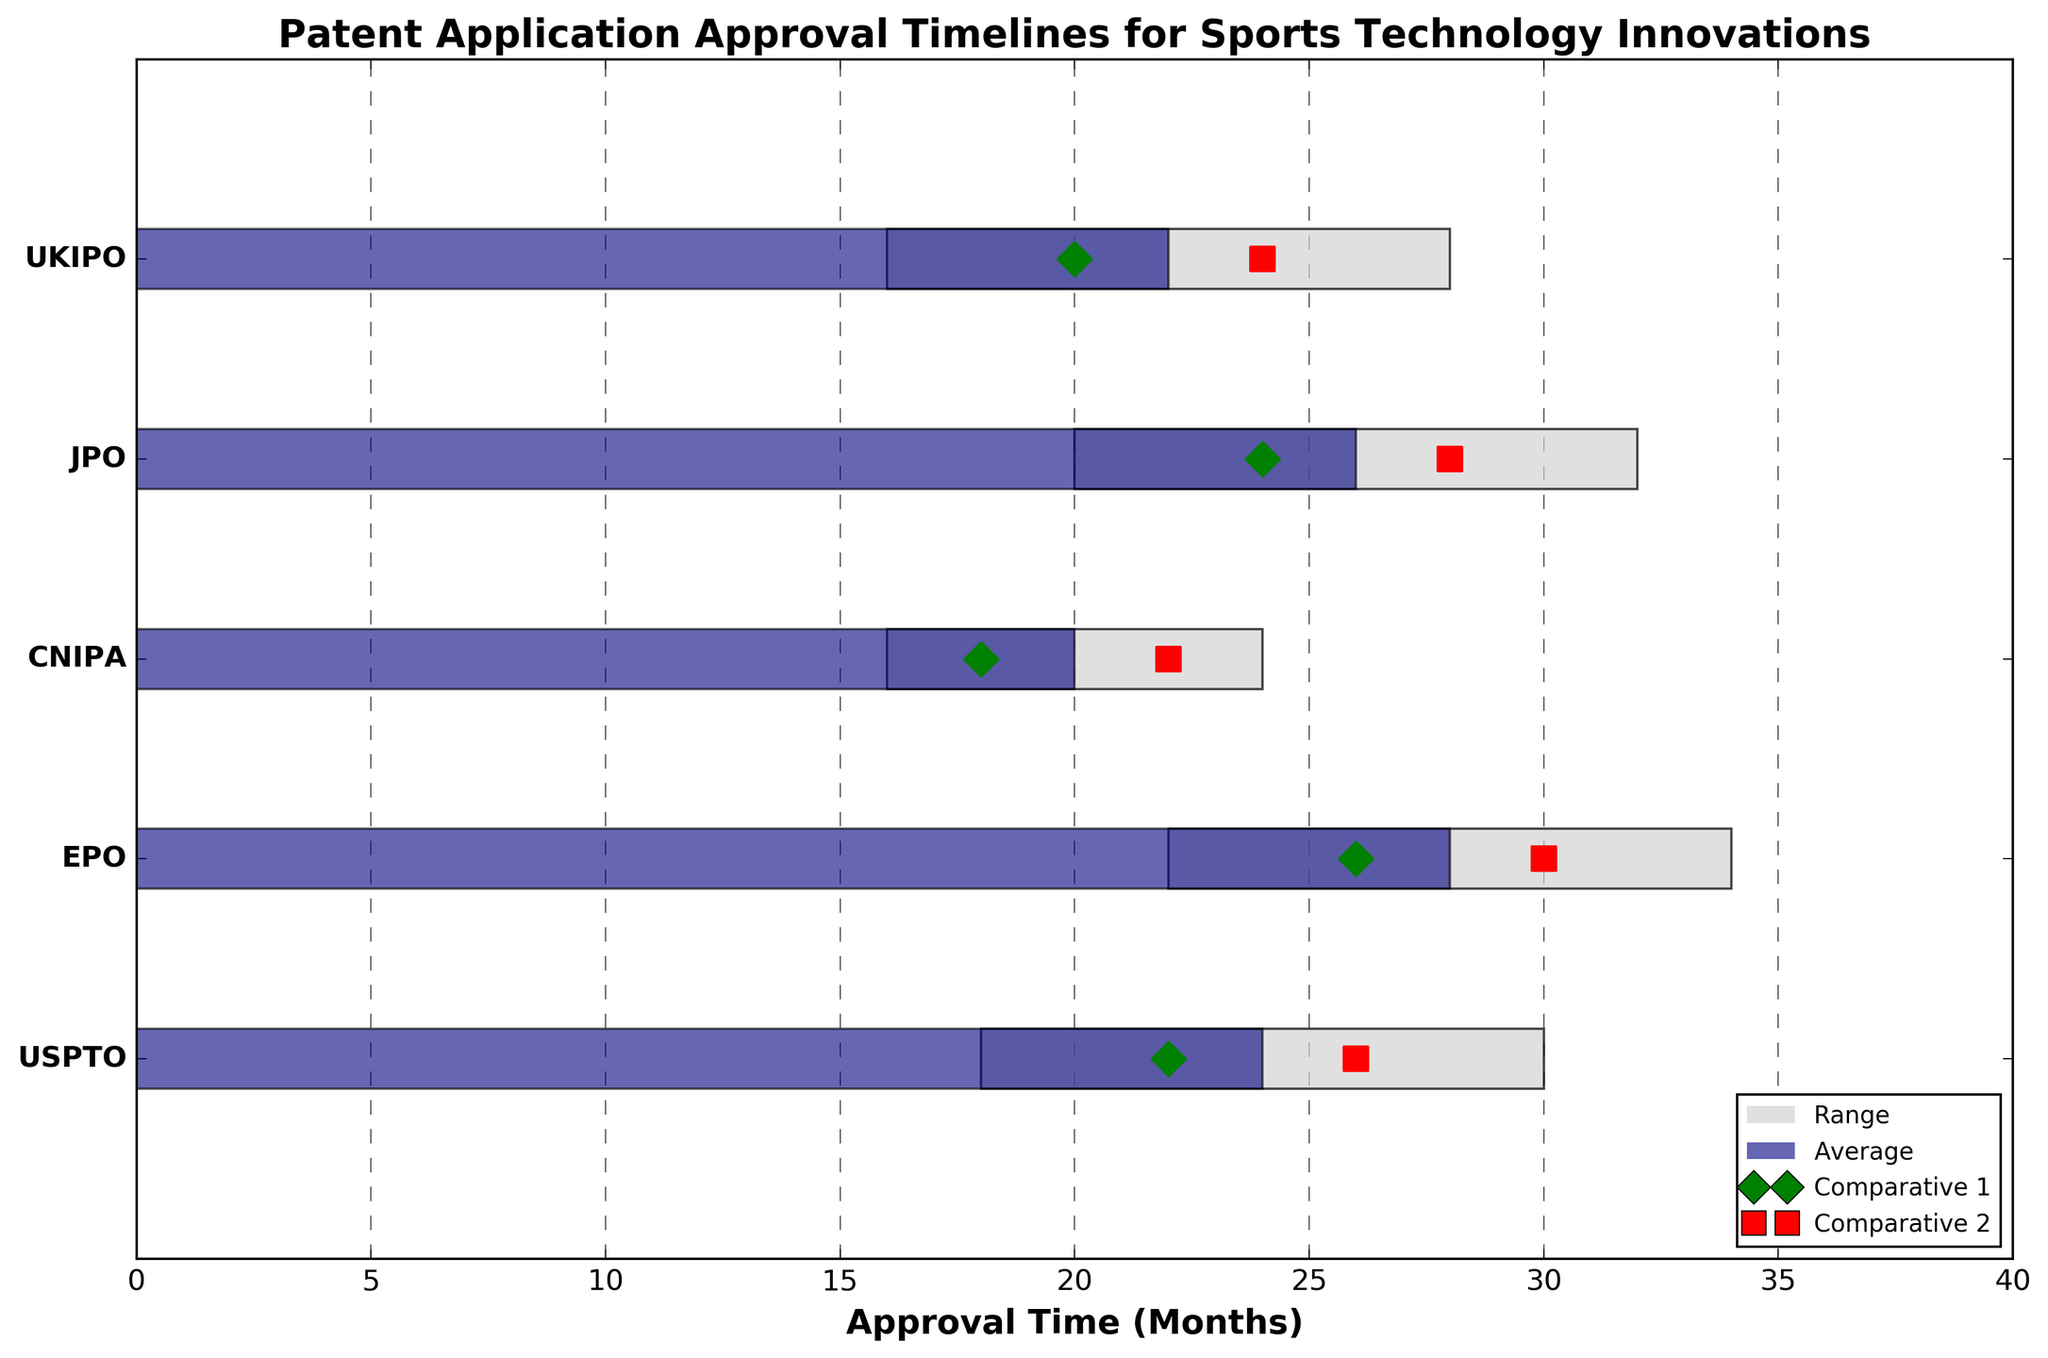What is the title of the chart? The title of the chart is usually at the top and is written larger and in bold for emphasis. We see the title: "Patent Application Approval Timelines for Sports Technology Innovations".
Answer: Patent Application Approval Timelines for Sports Technology Innovations Which patent office has the shortest average approval time? To find the shortest approval time, compare the average times for each patent office. The data shows: USPTO (24 months), EPO (28 months), CNIPA (20 months), JPO (26 months), UKIPO (22 months). The CNIPA has the shortest average approval time of 20 months.
Answer: CNIPA What is the approval time range for EPO? Find EPO's row and locate the horizontal range bar. The range starts at 22 months and ends at 34 months.
Answer: 22 to 34 months Which patent office's Comparative 1 marker is the closest to its average approval time? Look at the green diamond markers (Comparative 1) and compare them to the blue bars (average approval time). USPTO's Comparative 1 (22) is closest to its average (24), being just 2 months off. Other offices' markers are farther away.
Answer: USPTO Which comparative marker (Comparative 1 or Comparative 2) is usually higher in approval times for the offices? Compare the green diamonds (Comparative 1) and red squares (Comparative 2) for each office. You can see that for most offices (e.g., USPTO, EPO, JPO, UKIPO), Comparative 2 (red square) is higher.
Answer: Comparative 2 What is the difference between the range start and range end for JPO? Identify JPO's range, starting at 20 months and ending at 32 months. Subtract the start from the end: 32 - 20 = 12 months.
Answer: 12 months How do the average approval times for USPTO and UKIPO compare? USPTO's average approval time is 24 months, while UKIPO's is 22 months. Therefore, USPTO's approval time is 2 months longer than UKIPO's.
Answer: USPTO is 2 months longer What is the average range (interval) length across all the patent offices? Calculate each interval: USPTO (30-18=12), EPO (34-22=12), CNIPA (24-16=8), JPO (32-20=12), UKIPO (28-16=12). Sum these intervals: 12 + 12 + 8 + 12 + 12 = 56. There are 5 offices, so the average range length is 56/5 = 11.2 months.
Answer: 11.2 months Which patent office shows the largest discrepancy between its Comparative 1 and Comparative 2 markers? Calculate the absolute differences: USPTO (26-22=4), EPO (30-26=4), CNIPA (22-18=4), JPO (28-24=4), UKIPO (24-20=4). All patent offices have the same discrepancy of 4 months.
Answer: All offices have the same 4 months discrepancy 